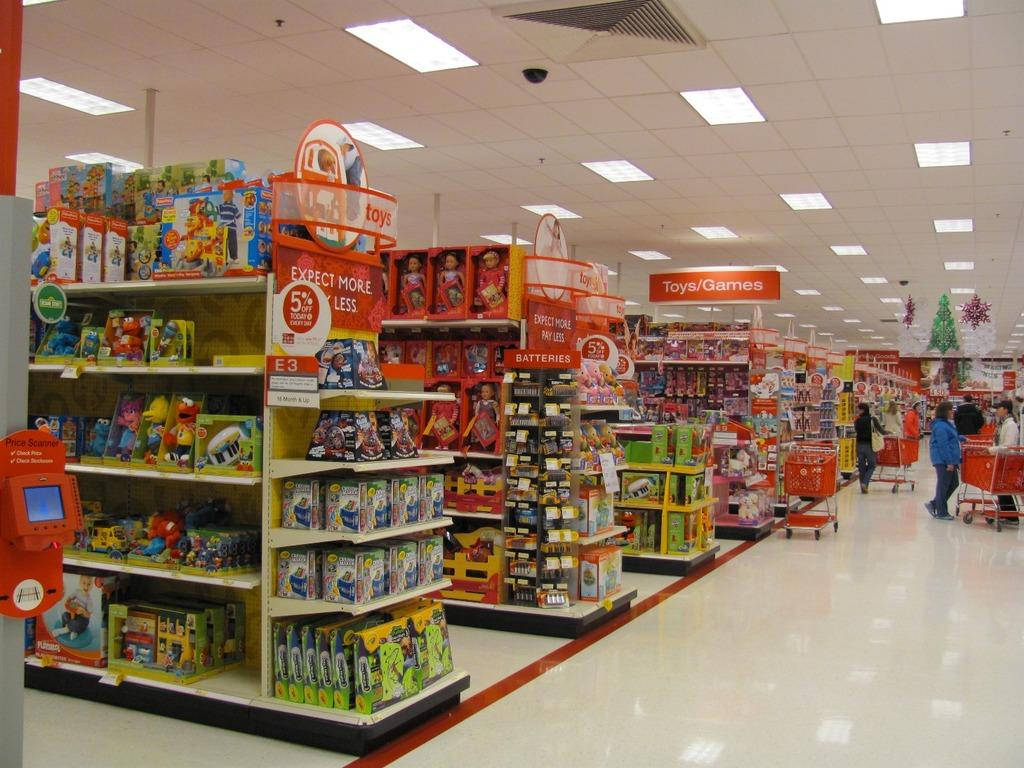<image>
Offer a succinct explanation of the picture presented. A toys and games section of a store is identified by a red sign. 